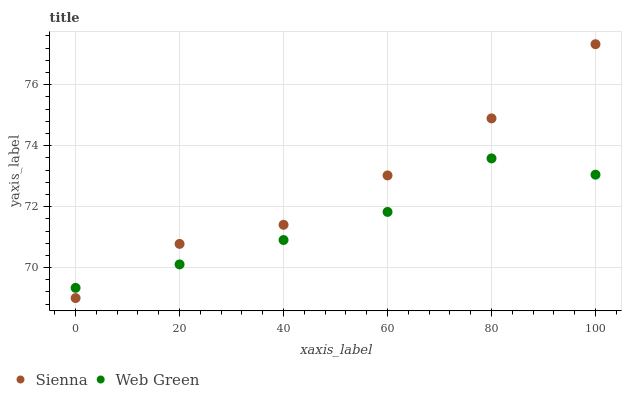Does Web Green have the minimum area under the curve?
Answer yes or no. Yes. Does Sienna have the maximum area under the curve?
Answer yes or no. Yes. Does Web Green have the maximum area under the curve?
Answer yes or no. No. Is Sienna the smoothest?
Answer yes or no. Yes. Is Web Green the roughest?
Answer yes or no. Yes. Is Web Green the smoothest?
Answer yes or no. No. Does Sienna have the lowest value?
Answer yes or no. Yes. Does Web Green have the lowest value?
Answer yes or no. No. Does Sienna have the highest value?
Answer yes or no. Yes. Does Web Green have the highest value?
Answer yes or no. No. Does Web Green intersect Sienna?
Answer yes or no. Yes. Is Web Green less than Sienna?
Answer yes or no. No. Is Web Green greater than Sienna?
Answer yes or no. No. 